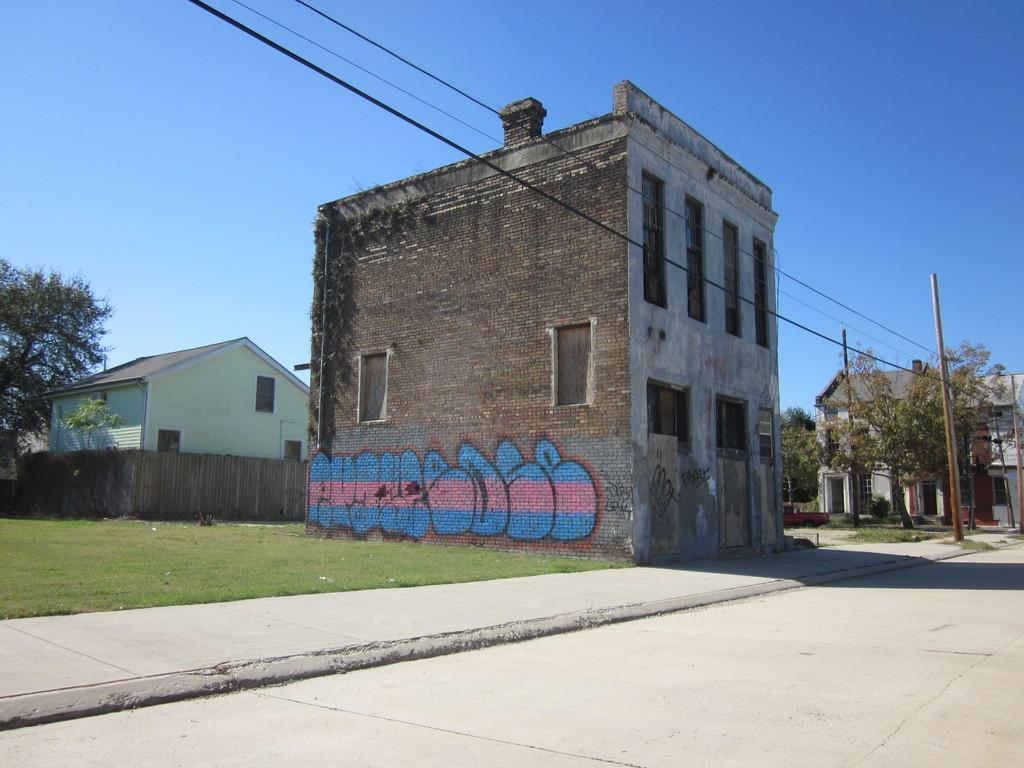What type of structures can be seen in the image? There are buildings in the image. Can you describe any specific details about the buildings? There is graffiti on the wall of a building. What type of vegetation is present in the image? There are trees in the image, and there is grass on the ground. What are the poles used for in the image? The purpose of the poles is not specified, but they could be for streetlights, signs, or other utilities. What color is the sky in the image? The sky is blue in the image. How many cakes are being shared between the brothers in the image? There are no cakes or brothers present in the image. What sense is being evoked by the image? The image does not evoke a specific sense, as it is a visual representation. 